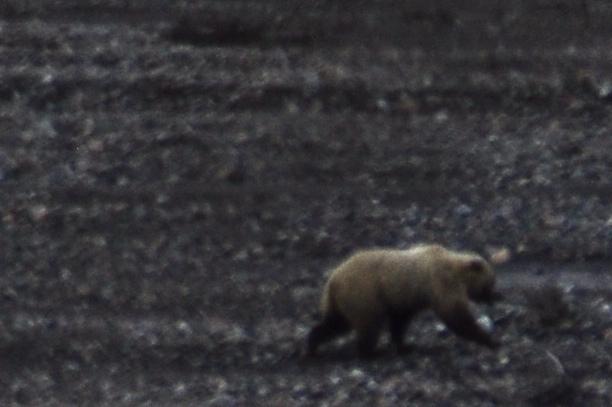What type of bear is this?
Quick response, please. Grizzly. Does the bear stand out more without snow?
Short answer required. No. What animal is this?
Keep it brief. Bear. Is this picture blurry?
Quick response, please. Yes. Does this picture show a mammal?
Answer briefly. Yes. What color is the animal?
Short answer required. Brown. 